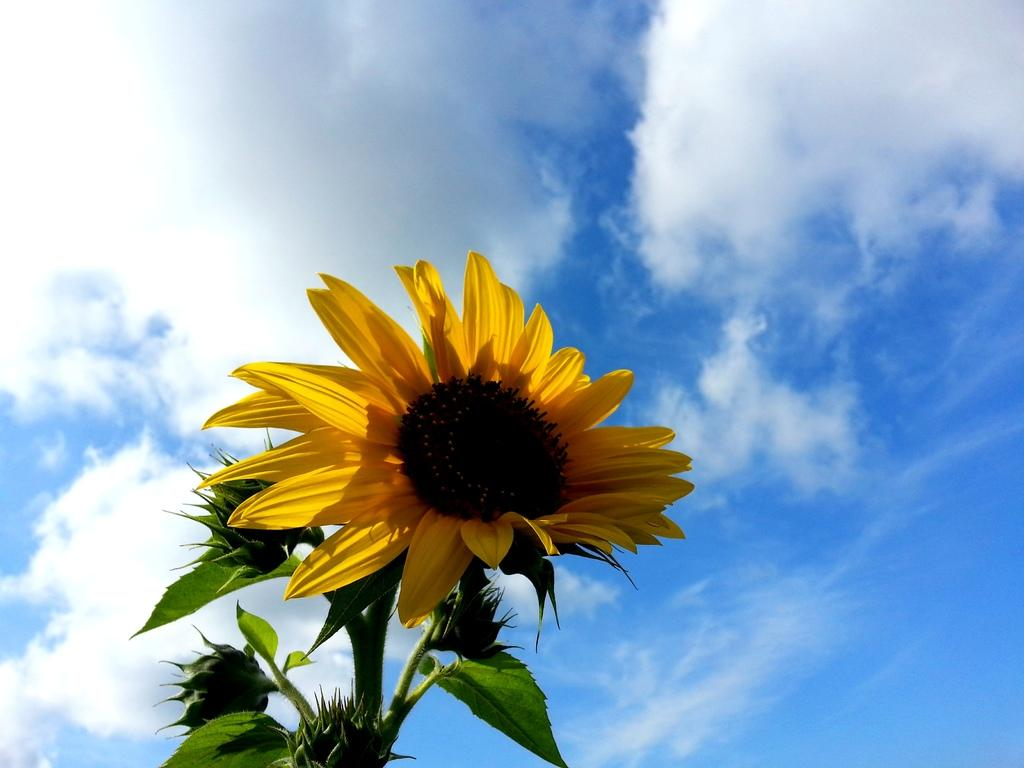What type of plant can be seen in the image? There is a plant with flowers in the image. What color are the flowers on the plant? The flower is yellow in color. What are the main features of the flower? The flower has petals. What can be seen in the background of the image? There is a sky visible in the image. What is the condition of the sky in the image? Clouds are present in the sky. How many balls are visible in the image? There are no balls present in the image. What type of vest is the plant wearing in the image? The plant is not wearing a vest, as it is a living organism and not a person. --- Facts: 1. There is a car in the image. 2. The car is red. 3. The car has four wheels. 4. There is a road visible in the image. 5. The road is paved. Absurd Topics: parrot, ocean, bicycle Conversation: What type of vehicle is in the image? There is a car in the image. What color is the car? The car is red. How many wheels does the car have? The car has four wheels. What can be seen in the background of the image? There is a road visible in the image. What is the condition of the road in the image? The road is paved. Reasoning: Let's think step by step in order to produce the conversation. We start by identifying the main subject of the image, which is the car. Then, we describe the specific characteristics of the car, such as its color and number of wheels. Next, we mention the background of the image, which includes the road. Finally, we describe the road's condition, which is that it is paved. Absurd Question/Answer: Can you see a parrot flying over the car in the image? There is no parrot present in the image. Is the car riding on the ocean in the image? The image does not depict the car riding on the ocean; it shows the car on a paved road. 